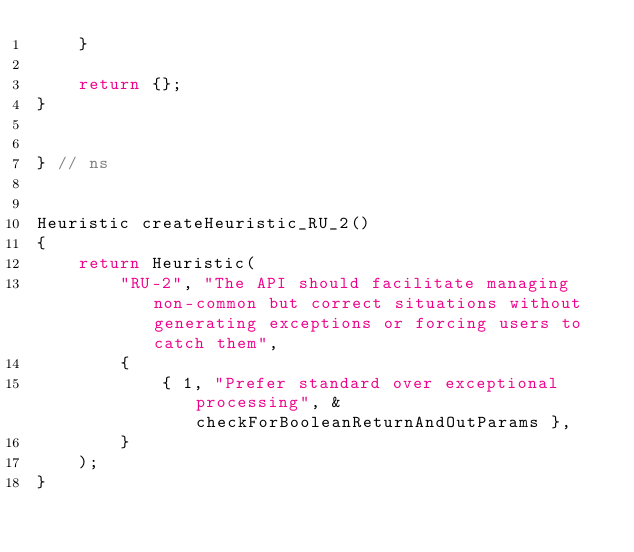<code> <loc_0><loc_0><loc_500><loc_500><_C++_>    }

    return {};
}


} // ns


Heuristic createHeuristic_RU_2()
{
    return Heuristic(
        "RU-2", "The API should facilitate managing non-common but correct situations without generating exceptions or forcing users to catch them",
        {
            { 1, "Prefer standard over exceptional processing", &checkForBooleanReturnAndOutParams },
        }
    );
}
</code> 